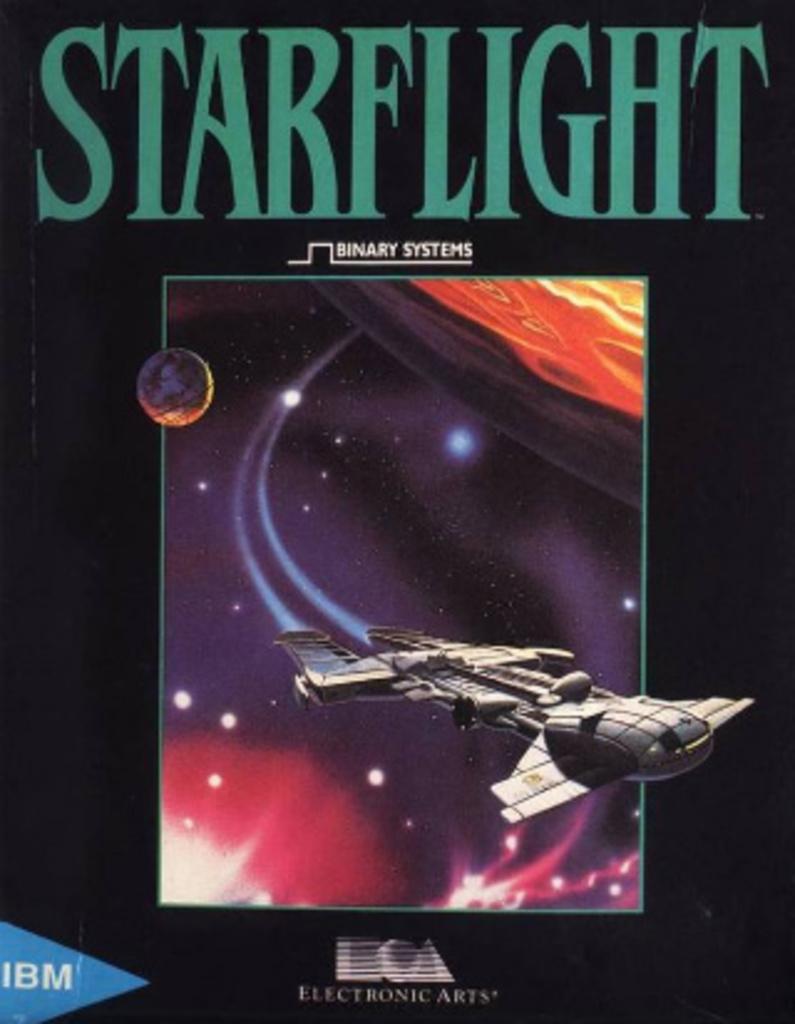Is this a movie ad?
Ensure brevity in your answer.  No. What is the name of this book?
Provide a succinct answer. Starflight. 